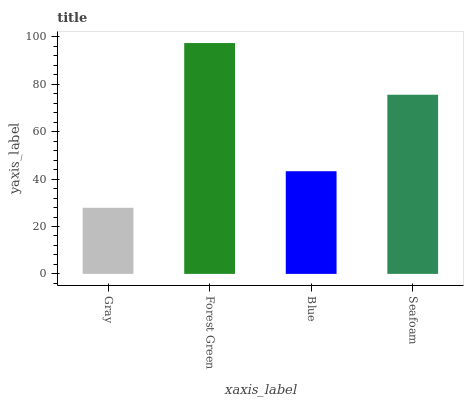Is Blue the minimum?
Answer yes or no. No. Is Blue the maximum?
Answer yes or no. No. Is Forest Green greater than Blue?
Answer yes or no. Yes. Is Blue less than Forest Green?
Answer yes or no. Yes. Is Blue greater than Forest Green?
Answer yes or no. No. Is Forest Green less than Blue?
Answer yes or no. No. Is Seafoam the high median?
Answer yes or no. Yes. Is Blue the low median?
Answer yes or no. Yes. Is Forest Green the high median?
Answer yes or no. No. Is Seafoam the low median?
Answer yes or no. No. 